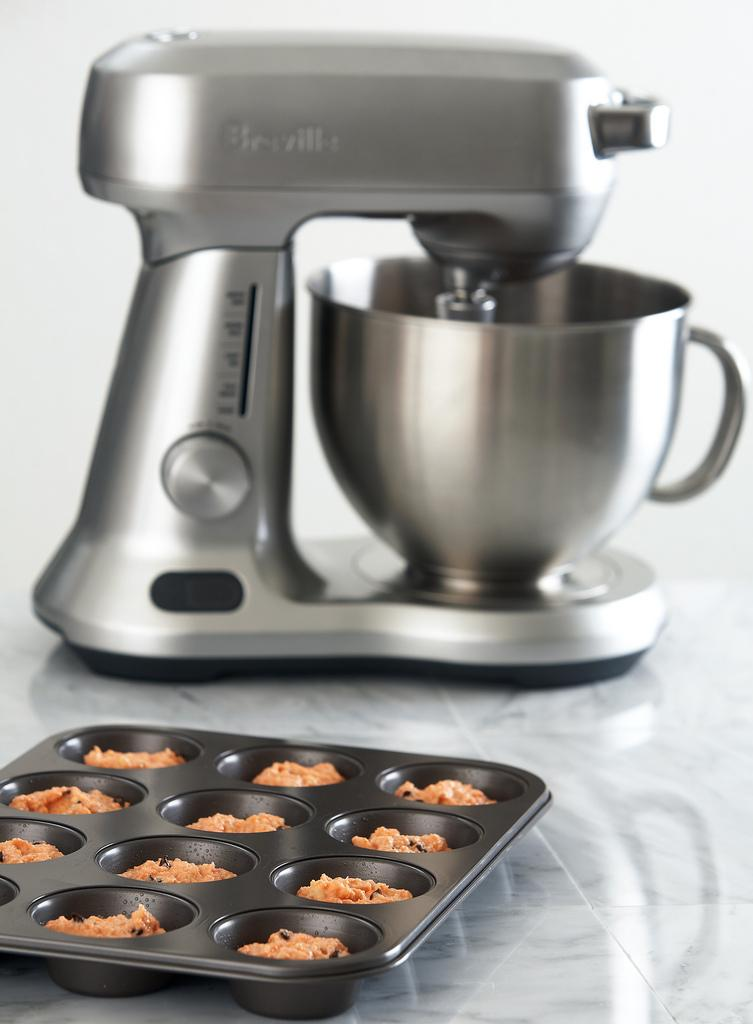What type of food item can be seen in the foreground of the image? There are cookies in a black tray in the foreground of the image. What appliance is visible in the background of the image? There is a mixer in the background of the image. What is the surface on which the mixer is placed? The mixer is on a stone surface. What type of silk fabric is draped over the mixer in the image? There is no silk fabric present in the image; the mixer is on a stone surface. What type of humor can be observed in the image? There is no humor depicted in the image; it shows cookies in a tray and a mixer on a stone surface. 